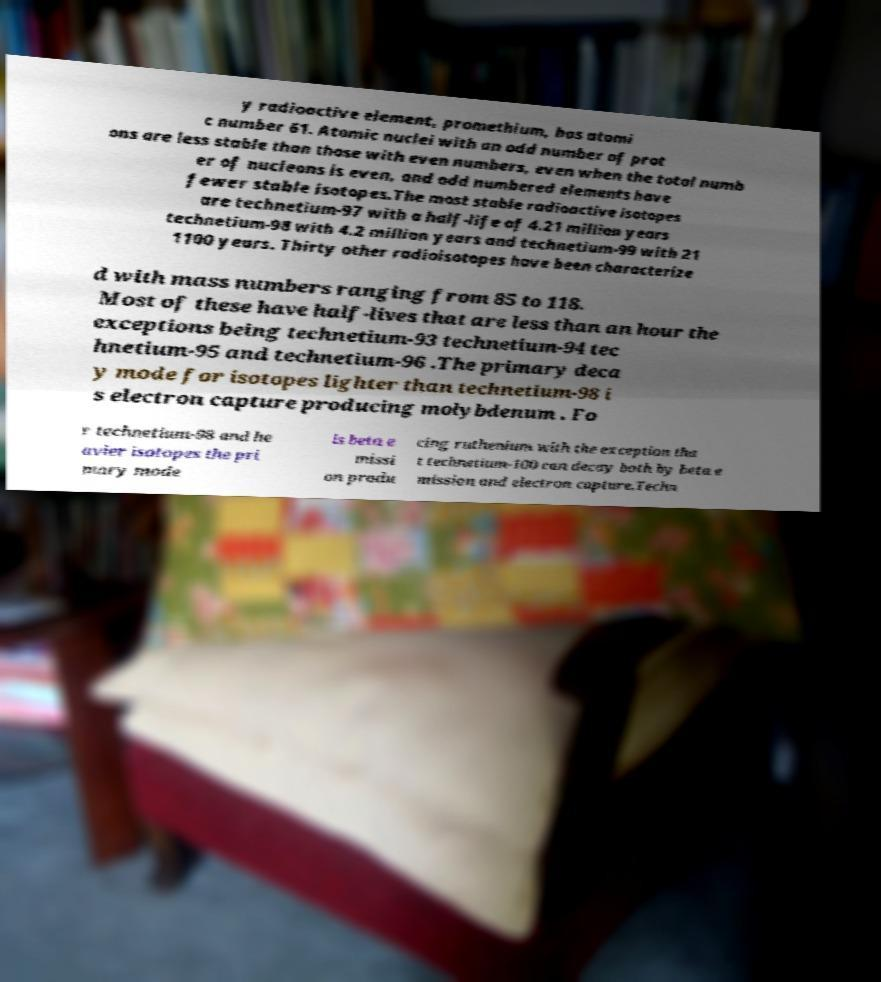Could you assist in decoding the text presented in this image and type it out clearly? y radioactive element, promethium, has atomi c number 61. Atomic nuclei with an odd number of prot ons are less stable than those with even numbers, even when the total numb er of nucleons is even, and odd numbered elements have fewer stable isotopes.The most stable radioactive isotopes are technetium-97 with a half-life of 4.21 million years technetium-98 with 4.2 million years and technetium-99 with 21 1100 years. Thirty other radioisotopes have been characterize d with mass numbers ranging from 85 to 118. Most of these have half-lives that are less than an hour the exceptions being technetium-93 technetium-94 tec hnetium-95 and technetium-96 .The primary deca y mode for isotopes lighter than technetium-98 i s electron capture producing molybdenum . Fo r technetium-98 and he avier isotopes the pri mary mode is beta e missi on produ cing ruthenium with the exception tha t technetium-100 can decay both by beta e mission and electron capture.Techn 